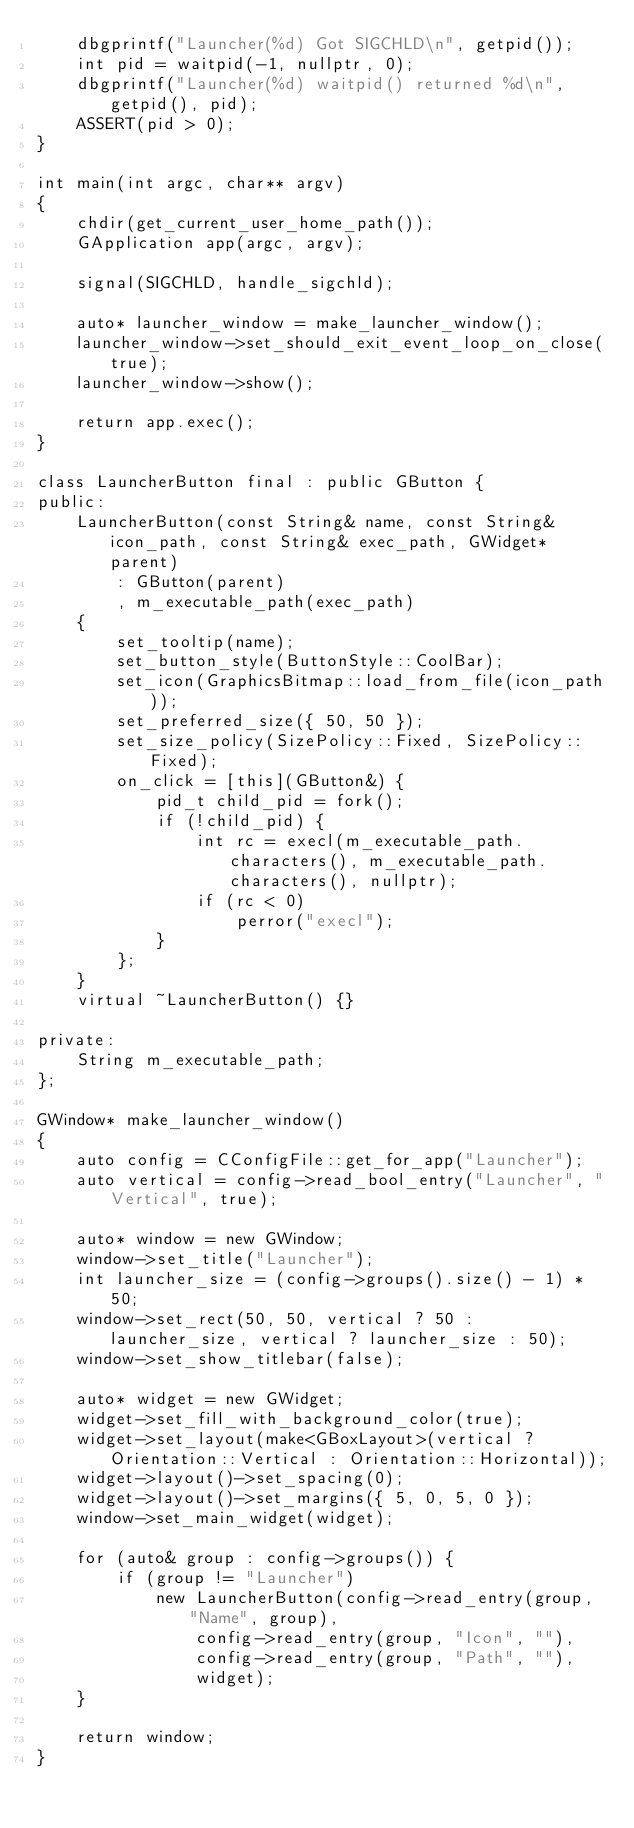Convert code to text. <code><loc_0><loc_0><loc_500><loc_500><_C++_>    dbgprintf("Launcher(%d) Got SIGCHLD\n", getpid());
    int pid = waitpid(-1, nullptr, 0);
    dbgprintf("Launcher(%d) waitpid() returned %d\n", getpid(), pid);
    ASSERT(pid > 0);
}

int main(int argc, char** argv)
{
    chdir(get_current_user_home_path());
    GApplication app(argc, argv);

    signal(SIGCHLD, handle_sigchld);

    auto* launcher_window = make_launcher_window();
    launcher_window->set_should_exit_event_loop_on_close(true);
    launcher_window->show();

    return app.exec();
}

class LauncherButton final : public GButton {
public:
    LauncherButton(const String& name, const String& icon_path, const String& exec_path, GWidget* parent)
        : GButton(parent)
        , m_executable_path(exec_path)
    {
        set_tooltip(name);
        set_button_style(ButtonStyle::CoolBar);
        set_icon(GraphicsBitmap::load_from_file(icon_path));
        set_preferred_size({ 50, 50 });
        set_size_policy(SizePolicy::Fixed, SizePolicy::Fixed);
        on_click = [this](GButton&) {
            pid_t child_pid = fork();
            if (!child_pid) {
                int rc = execl(m_executable_path.characters(), m_executable_path.characters(), nullptr);
                if (rc < 0)
                    perror("execl");
            }
        };
    }
    virtual ~LauncherButton() {}

private:
    String m_executable_path;
};

GWindow* make_launcher_window()
{
    auto config = CConfigFile::get_for_app("Launcher");
    auto vertical = config->read_bool_entry("Launcher", "Vertical", true);

    auto* window = new GWindow;
    window->set_title("Launcher");
    int launcher_size = (config->groups().size() - 1) * 50;
    window->set_rect(50, 50, vertical ? 50 : launcher_size, vertical ? launcher_size : 50);
    window->set_show_titlebar(false);

    auto* widget = new GWidget;
    widget->set_fill_with_background_color(true);
    widget->set_layout(make<GBoxLayout>(vertical ? Orientation::Vertical : Orientation::Horizontal));
    widget->layout()->set_spacing(0);
    widget->layout()->set_margins({ 5, 0, 5, 0 });
    window->set_main_widget(widget);

    for (auto& group : config->groups()) {
        if (group != "Launcher")
            new LauncherButton(config->read_entry(group, "Name", group),
                config->read_entry(group, "Icon", ""),
                config->read_entry(group, "Path", ""),
                widget);
    }

    return window;
}
</code> 